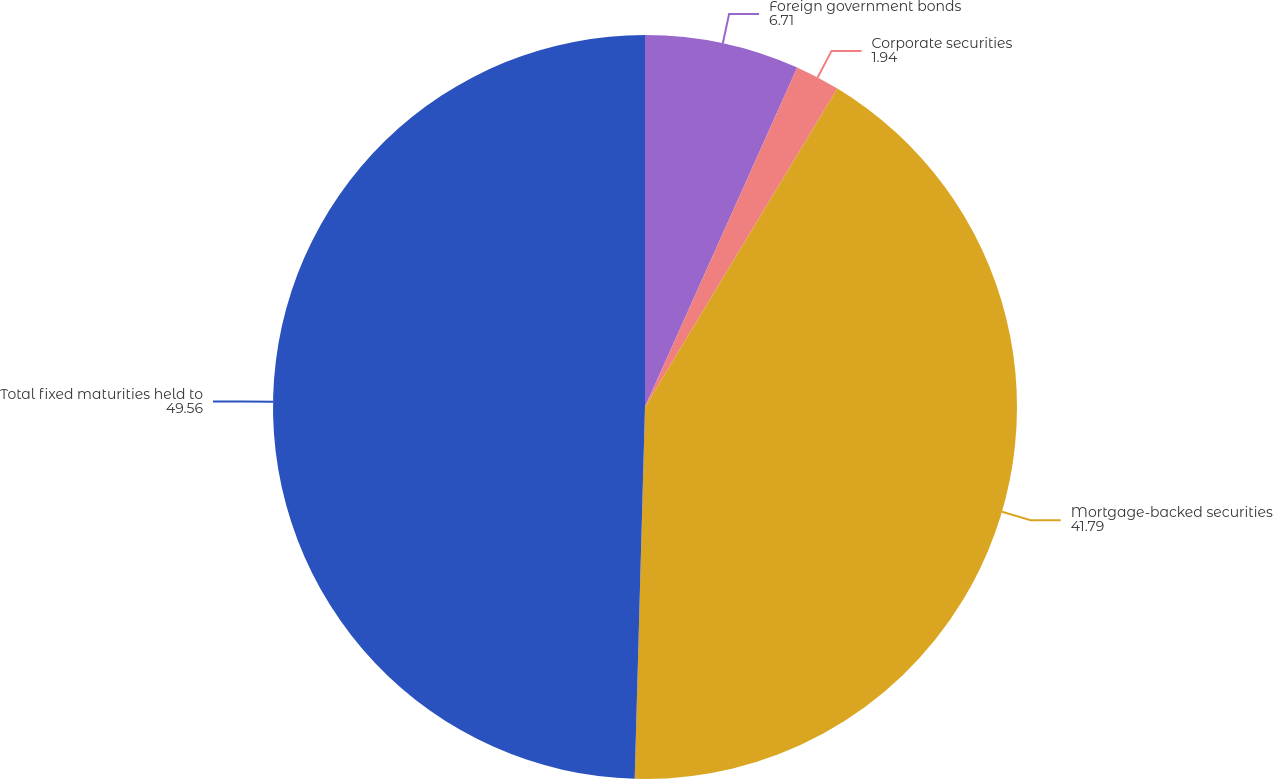Convert chart. <chart><loc_0><loc_0><loc_500><loc_500><pie_chart><fcel>Foreign government bonds<fcel>Corporate securities<fcel>Mortgage-backed securities<fcel>Total fixed maturities held to<nl><fcel>6.71%<fcel>1.94%<fcel>41.79%<fcel>49.56%<nl></chart> 